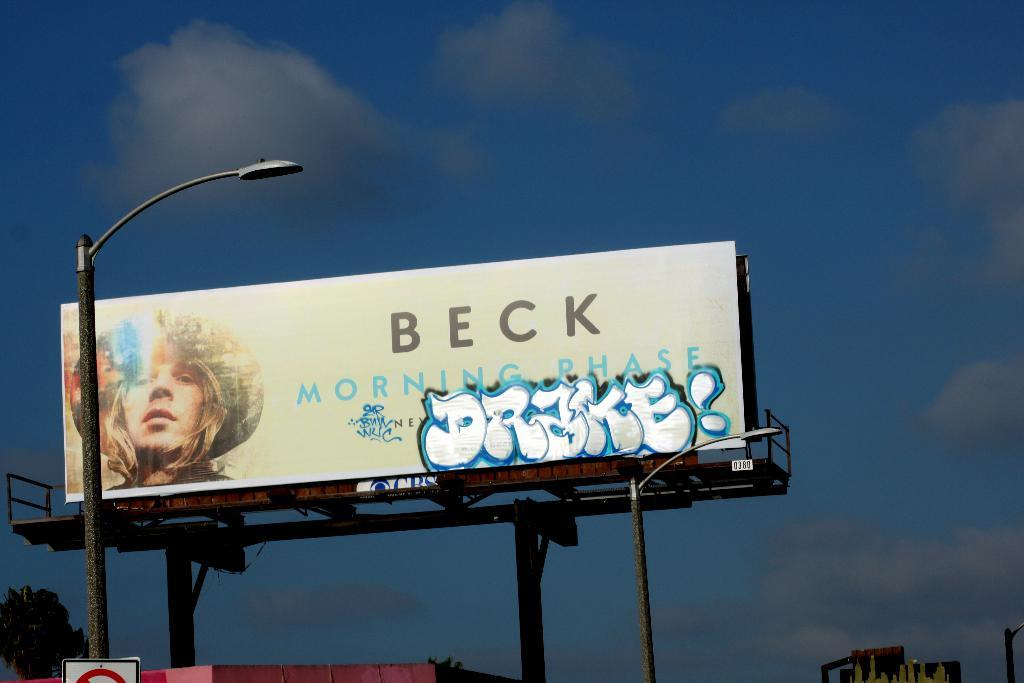<image>
Give a short and clear explanation of the subsequent image. A billboard advertising Becks album Morning Phase with graphitii 